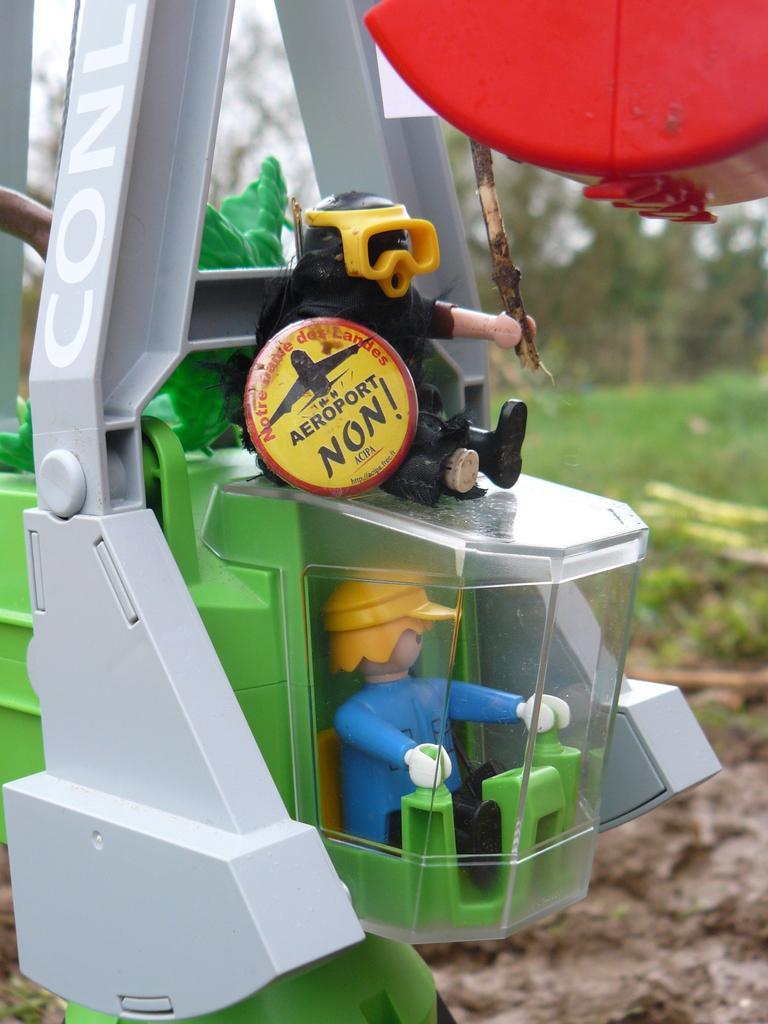In one or two sentences, can you explain what this image depicts? In the center of the image there is a toy. In the background there are trees, grass and sky. 